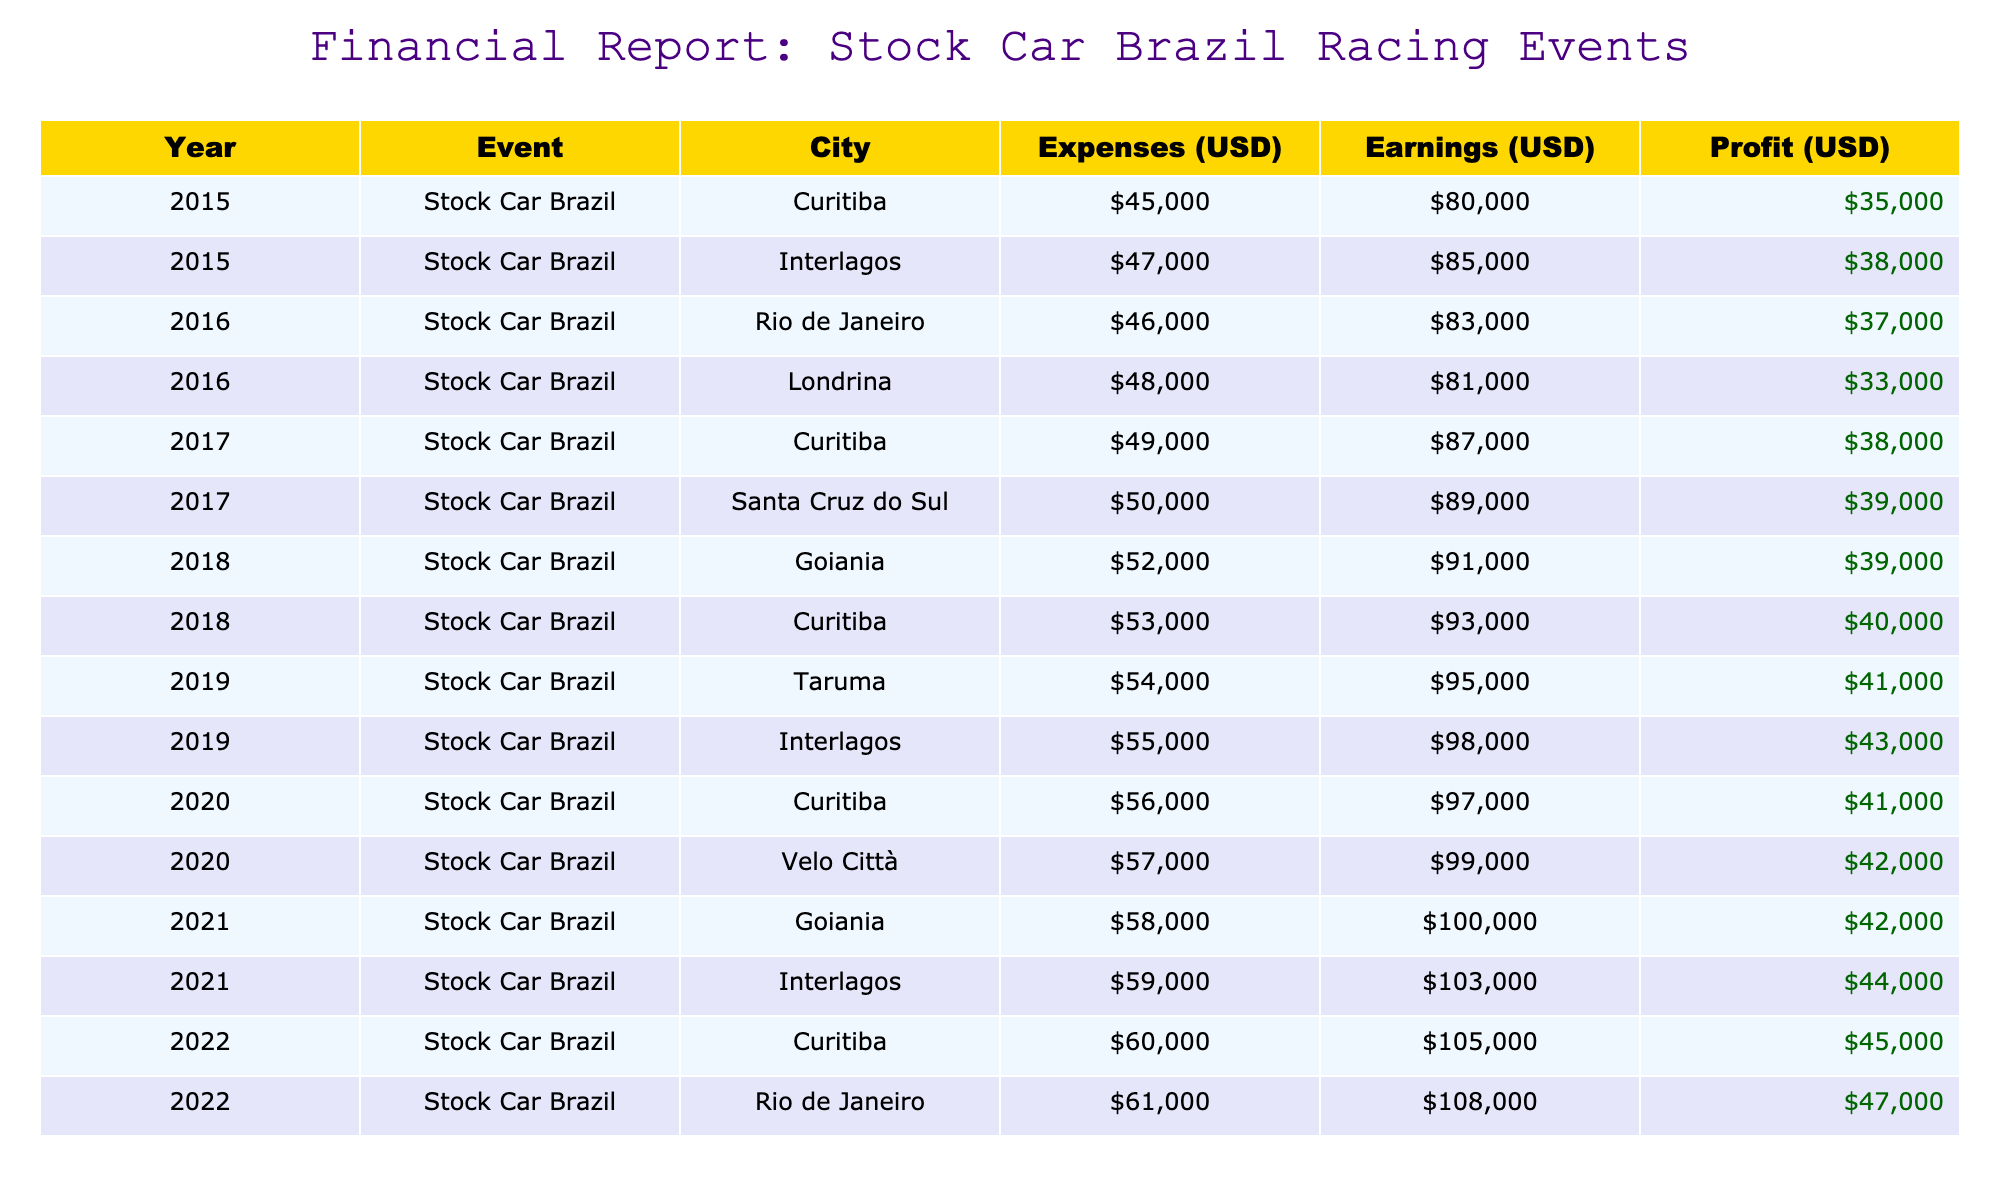What were the total expenses in 2019 for all events? In 2019, there are two events with the following expenses: Taruma has expenses of 54000 and Interlagos has expenses of 55000. The total expenses for these events is 54000 + 55000 = 109000.
Answer: 109000 What was the highest earning year and how much was earned? By reviewing each year's total earnings from the events, 2022 has the highest earning of 105000 (Curitiba) and 108000 (Rio de Janeiro), making the maximum for the year 2022 equal to 108000.
Answer: 2022, 108000 What was the average profit made from all the events in 2018? The profits from 2018's events are calculated as follows: Goiania (91000 - 52000 = 39000) and Curitiba (93000 - 53000 = 40000). The average profit for 2018 is (39000 + 40000) / 2 = 39500.
Answer: 39500 Did any event in 2015 have earnings less than 80000? By checking the earnings for the events in 2015, both events (Curitiba and Interlagos) had earnings of 80000 and 85000, respectively. Therefore, no events had earnings less than 80000.
Answer: No Which year had the largest expense for a single event, and what was the amount? In checking the expenses for each event for all years, the highest expense was found in 2022's Rio de Janeiro event, with expenses of 61000.
Answer: 2022, 61000 What is the total profit made over all the events in 2020? The profits for 2020's events are: Curitiba (97000 - 56000 = 41000) and Velo Città (99000 - 57000 = 42000). The total profit for the year is 41000 + 42000 = 83000.
Answer: 83000 Was the profit from the 2016 events greater than the profit from the 2019 events? For 2016, the profits were Rio de Janeiro (83000 - 46000 = 37000) and Londrina (81000 - 48000 = 33000), totaling 70000. For 2019, the profits were Taruma (95000 - 54000 = 41000) and Interlagos (98000 - 55000 = 43000), totaling 84000. Since 70000 < 84000, the profit from 2016 was not greater than 2019.
Answer: No What were the earnings of the 2017 events combined? The earnings for 2017 are: Curitiba (87000) and Santa Cruz do Sul (89000). Adding these, the total earnings for the year 2017 are 87000 + 89000 = 176000.
Answer: 176000 What was the change in profit from 2015 to 2022? Calculate the profits: In 2015, the profits were 80000 - 45000 = 35000 (Curitiba) and 85000 - 47000 = 38000 (Interlagos), totaling 73000. For 2022, the profits are: 105000 - 60000 = 45000 (Curitiba) and 108000 - 61000 = 47000 (Rio de Janeiro), totaling 92000. The change in profit is 92000 - 73000 = 19000 increase.
Answer: 19000 increase 